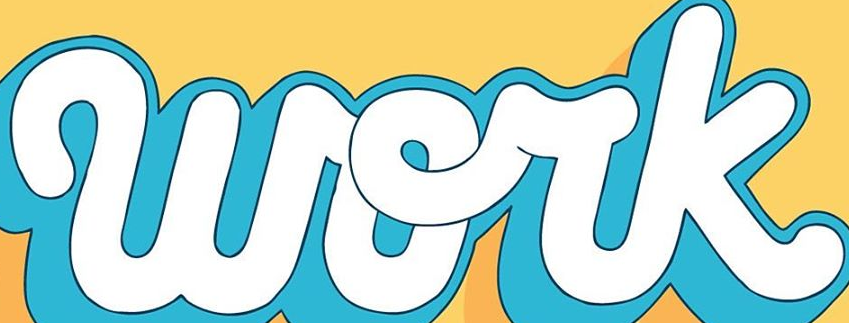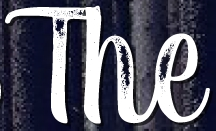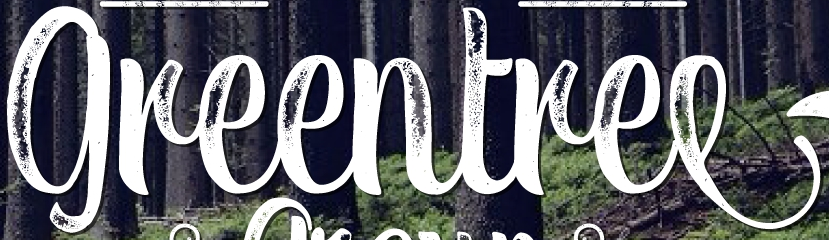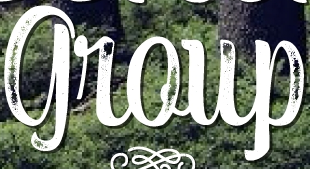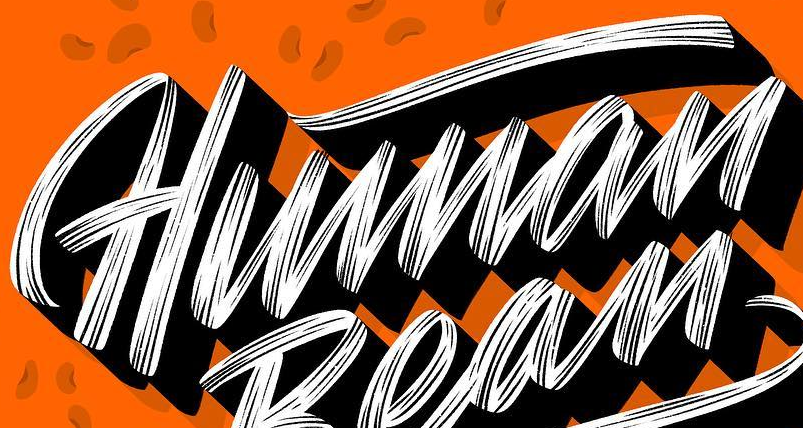Identify the words shown in these images in order, separated by a semicolon. work; The; greentree; group; Human 